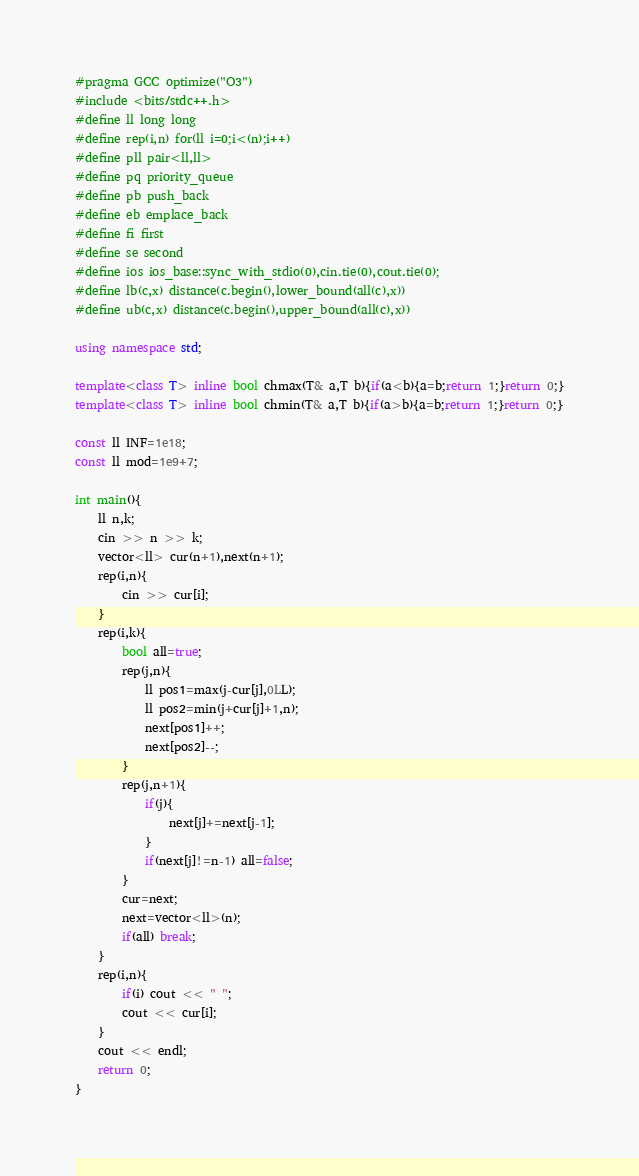<code> <loc_0><loc_0><loc_500><loc_500><_C++_>#pragma GCC optimize("O3")
#include <bits/stdc++.h>
#define ll long long
#define rep(i,n) for(ll i=0;i<(n);i++)
#define pll pair<ll,ll>
#define pq priority_queue
#define pb push_back
#define eb emplace_back
#define fi first
#define se second
#define ios ios_base::sync_with_stdio(0),cin.tie(0),cout.tie(0);
#define lb(c,x) distance(c.begin(),lower_bound(all(c),x))
#define ub(c,x) distance(c.begin(),upper_bound(all(c),x))

using namespace std;

template<class T> inline bool chmax(T& a,T b){if(a<b){a=b;return 1;}return 0;}
template<class T> inline bool chmin(T& a,T b){if(a>b){a=b;return 1;}return 0;}

const ll INF=1e18;
const ll mod=1e9+7;

int main(){
    ll n,k;
    cin >> n >> k;
    vector<ll> cur(n+1),next(n+1);
    rep(i,n){
        cin >> cur[i];
    }
    rep(i,k){
        bool all=true;
        rep(j,n){
            ll pos1=max(j-cur[j],0LL);
            ll pos2=min(j+cur[j]+1,n);
            next[pos1]++;
            next[pos2]--;
        }
        rep(j,n+1){
            if(j){
                next[j]+=next[j-1];
            }
            if(next[j]!=n-1) all=false;
        }
        cur=next;
        next=vector<ll>(n);
        if(all) break;
    }
    rep(i,n){
        if(i) cout << " ";
        cout << cur[i];
    }
    cout << endl;
    return 0;
}
</code> 